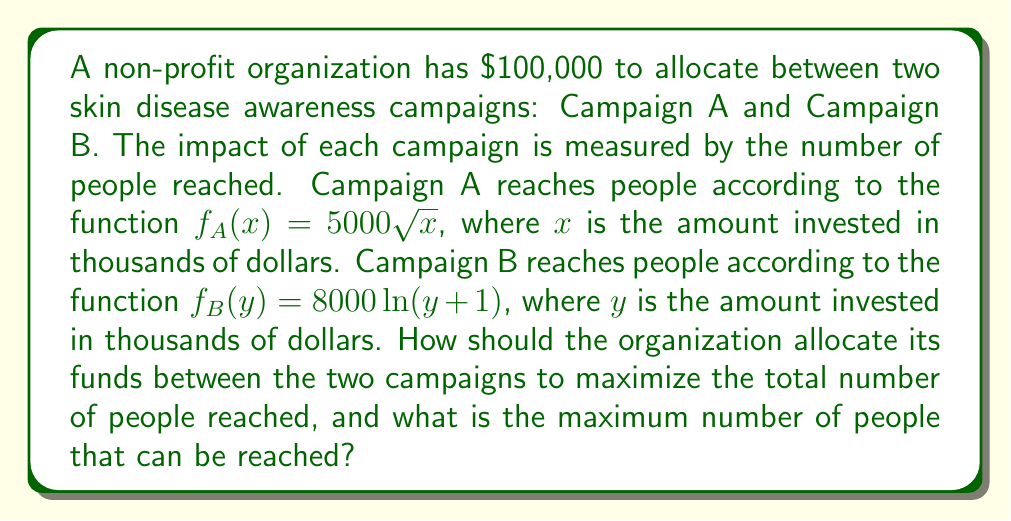Can you answer this question? To solve this optimization problem, we need to:

1. Set up the objective function
2. Apply the constraint
3. Use the method of Lagrange multipliers to find the optimal allocation

Step 1: Set up the objective function

Let $x$ be the amount (in thousands) allocated to Campaign A, and $y$ be the amount (in thousands) allocated to Campaign B. The total number of people reached is:

$$T(x,y) = f_A(x) + f_B(y) = 5000\sqrt{x} + 8000\ln(y+1)$$

Step 2: Apply the constraint

The total budget is $100,000, so our constraint is:

$$x + y = 100$$

Step 3: Use the method of Lagrange multipliers

We form the Lagrangian function:

$$L(x,y,\lambda) = 5000\sqrt{x} + 8000\ln(y+1) - \lambda(x + y - 100)$$

Now, we take partial derivatives and set them equal to zero:

$$\frac{\partial L}{\partial x} = \frac{2500}{\sqrt{x}} - \lambda = 0$$
$$\frac{\partial L}{\partial y} = \frac{8000}{y+1} - \lambda = 0$$
$$\frac{\partial L}{\partial \lambda} = x + y - 100 = 0$$

From the first two equations:

$$\frac{2500}{\sqrt{x}} = \frac{8000}{y+1}$$

Cross-multiplying:

$$2500(y+1) = 8000\sqrt{x}$$
$$(y+1)^2 = 10.24x$$

Substituting $y = 100 - x$ from the constraint:

$$(101-x)^2 = 10.24x$$
$$10201 - 202x + x^2 = 10.24x$$
$$x^2 - 212.24x + 10201 = 0$$

Solving this quadratic equation:

$$x \approx 64.76$$

Therefore, $y \approx 35.24$

Step 4: Calculate the maximum number of people reached

$$T(64.76, 35.24) = 5000\sqrt{64.76} + 8000\ln(35.24+1) \approx 80,000$$
Answer: The organization should allocate approximately $64,760 to Campaign A and $35,240 to Campaign B. This allocation will reach a maximum of approximately 80,000 people. 